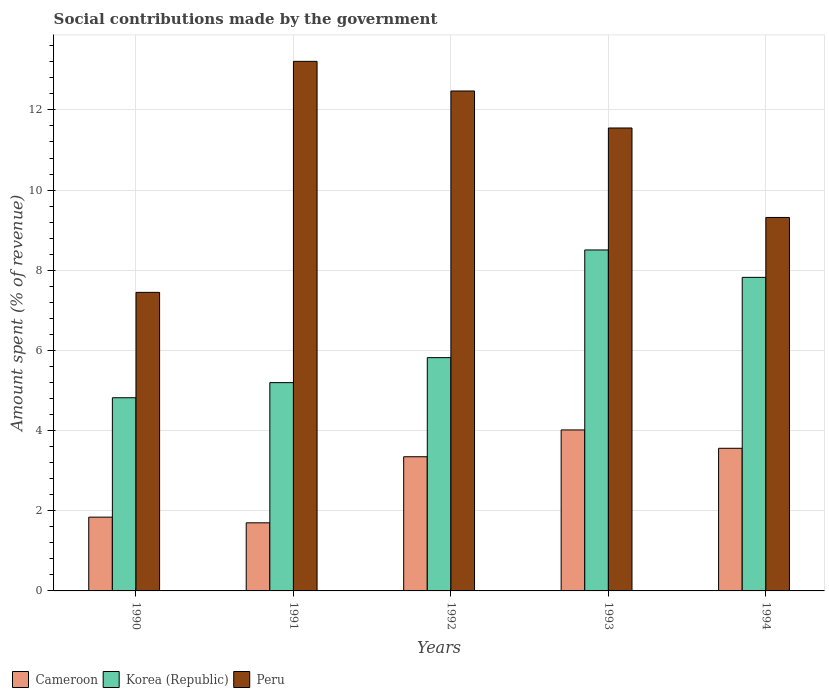How many different coloured bars are there?
Your response must be concise. 3. How many groups of bars are there?
Offer a very short reply. 5. How many bars are there on the 5th tick from the right?
Give a very brief answer. 3. In how many cases, is the number of bars for a given year not equal to the number of legend labels?
Keep it short and to the point. 0. What is the amount spent (in %) on social contributions in Korea (Republic) in 1994?
Keep it short and to the point. 7.82. Across all years, what is the maximum amount spent (in %) on social contributions in Korea (Republic)?
Your answer should be very brief. 8.51. Across all years, what is the minimum amount spent (in %) on social contributions in Peru?
Provide a succinct answer. 7.45. In which year was the amount spent (in %) on social contributions in Peru maximum?
Provide a short and direct response. 1991. What is the total amount spent (in %) on social contributions in Cameroon in the graph?
Give a very brief answer. 14.46. What is the difference between the amount spent (in %) on social contributions in Peru in 1990 and that in 1991?
Ensure brevity in your answer.  -5.76. What is the difference between the amount spent (in %) on social contributions in Peru in 1992 and the amount spent (in %) on social contributions in Cameroon in 1993?
Your answer should be very brief. 8.46. What is the average amount spent (in %) on social contributions in Cameroon per year?
Your answer should be very brief. 2.89. In the year 1992, what is the difference between the amount spent (in %) on social contributions in Cameroon and amount spent (in %) on social contributions in Korea (Republic)?
Your answer should be compact. -2.47. In how many years, is the amount spent (in %) on social contributions in Korea (Republic) greater than 8.4 %?
Your response must be concise. 1. What is the ratio of the amount spent (in %) on social contributions in Korea (Republic) in 1991 to that in 1994?
Your response must be concise. 0.66. What is the difference between the highest and the second highest amount spent (in %) on social contributions in Cameroon?
Give a very brief answer. 0.46. What is the difference between the highest and the lowest amount spent (in %) on social contributions in Peru?
Your answer should be compact. 5.76. In how many years, is the amount spent (in %) on social contributions in Cameroon greater than the average amount spent (in %) on social contributions in Cameroon taken over all years?
Ensure brevity in your answer.  3. Is the sum of the amount spent (in %) on social contributions in Cameroon in 1990 and 1993 greater than the maximum amount spent (in %) on social contributions in Peru across all years?
Offer a terse response. No. What does the 2nd bar from the left in 1991 represents?
Your response must be concise. Korea (Republic). What does the 1st bar from the right in 1991 represents?
Offer a very short reply. Peru. How many bars are there?
Keep it short and to the point. 15. How many years are there in the graph?
Give a very brief answer. 5. Does the graph contain any zero values?
Make the answer very short. No. Where does the legend appear in the graph?
Ensure brevity in your answer.  Bottom left. How many legend labels are there?
Ensure brevity in your answer.  3. What is the title of the graph?
Give a very brief answer. Social contributions made by the government. Does "Low income" appear as one of the legend labels in the graph?
Provide a succinct answer. No. What is the label or title of the X-axis?
Ensure brevity in your answer.  Years. What is the label or title of the Y-axis?
Your answer should be very brief. Amount spent (% of revenue). What is the Amount spent (% of revenue) of Cameroon in 1990?
Ensure brevity in your answer.  1.84. What is the Amount spent (% of revenue) in Korea (Republic) in 1990?
Ensure brevity in your answer.  4.82. What is the Amount spent (% of revenue) of Peru in 1990?
Offer a very short reply. 7.45. What is the Amount spent (% of revenue) of Cameroon in 1991?
Ensure brevity in your answer.  1.7. What is the Amount spent (% of revenue) of Korea (Republic) in 1991?
Keep it short and to the point. 5.2. What is the Amount spent (% of revenue) in Peru in 1991?
Ensure brevity in your answer.  13.21. What is the Amount spent (% of revenue) of Cameroon in 1992?
Give a very brief answer. 3.35. What is the Amount spent (% of revenue) of Korea (Republic) in 1992?
Ensure brevity in your answer.  5.82. What is the Amount spent (% of revenue) of Peru in 1992?
Make the answer very short. 12.47. What is the Amount spent (% of revenue) of Cameroon in 1993?
Offer a terse response. 4.02. What is the Amount spent (% of revenue) in Korea (Republic) in 1993?
Offer a very short reply. 8.51. What is the Amount spent (% of revenue) of Peru in 1993?
Keep it short and to the point. 11.55. What is the Amount spent (% of revenue) in Cameroon in 1994?
Make the answer very short. 3.56. What is the Amount spent (% of revenue) in Korea (Republic) in 1994?
Provide a succinct answer. 7.82. What is the Amount spent (% of revenue) in Peru in 1994?
Make the answer very short. 9.32. Across all years, what is the maximum Amount spent (% of revenue) in Cameroon?
Keep it short and to the point. 4.02. Across all years, what is the maximum Amount spent (% of revenue) of Korea (Republic)?
Offer a terse response. 8.51. Across all years, what is the maximum Amount spent (% of revenue) of Peru?
Provide a short and direct response. 13.21. Across all years, what is the minimum Amount spent (% of revenue) in Cameroon?
Offer a terse response. 1.7. Across all years, what is the minimum Amount spent (% of revenue) in Korea (Republic)?
Your answer should be very brief. 4.82. Across all years, what is the minimum Amount spent (% of revenue) in Peru?
Keep it short and to the point. 7.45. What is the total Amount spent (% of revenue) of Cameroon in the graph?
Your response must be concise. 14.46. What is the total Amount spent (% of revenue) in Korea (Republic) in the graph?
Provide a succinct answer. 32.16. What is the total Amount spent (% of revenue) of Peru in the graph?
Your answer should be compact. 54. What is the difference between the Amount spent (% of revenue) in Cameroon in 1990 and that in 1991?
Give a very brief answer. 0.14. What is the difference between the Amount spent (% of revenue) of Korea (Republic) in 1990 and that in 1991?
Your answer should be compact. -0.38. What is the difference between the Amount spent (% of revenue) in Peru in 1990 and that in 1991?
Your answer should be very brief. -5.76. What is the difference between the Amount spent (% of revenue) in Cameroon in 1990 and that in 1992?
Give a very brief answer. -1.51. What is the difference between the Amount spent (% of revenue) of Korea (Republic) in 1990 and that in 1992?
Give a very brief answer. -1. What is the difference between the Amount spent (% of revenue) of Peru in 1990 and that in 1992?
Ensure brevity in your answer.  -5.02. What is the difference between the Amount spent (% of revenue) in Cameroon in 1990 and that in 1993?
Provide a short and direct response. -2.18. What is the difference between the Amount spent (% of revenue) in Korea (Republic) in 1990 and that in 1993?
Offer a terse response. -3.69. What is the difference between the Amount spent (% of revenue) in Peru in 1990 and that in 1993?
Offer a terse response. -4.1. What is the difference between the Amount spent (% of revenue) of Cameroon in 1990 and that in 1994?
Your answer should be compact. -1.72. What is the difference between the Amount spent (% of revenue) of Korea (Republic) in 1990 and that in 1994?
Provide a short and direct response. -3. What is the difference between the Amount spent (% of revenue) of Peru in 1990 and that in 1994?
Provide a succinct answer. -1.87. What is the difference between the Amount spent (% of revenue) in Cameroon in 1991 and that in 1992?
Your answer should be compact. -1.65. What is the difference between the Amount spent (% of revenue) of Korea (Republic) in 1991 and that in 1992?
Offer a very short reply. -0.62. What is the difference between the Amount spent (% of revenue) of Peru in 1991 and that in 1992?
Give a very brief answer. 0.74. What is the difference between the Amount spent (% of revenue) of Cameroon in 1991 and that in 1993?
Offer a terse response. -2.32. What is the difference between the Amount spent (% of revenue) of Korea (Republic) in 1991 and that in 1993?
Your answer should be compact. -3.31. What is the difference between the Amount spent (% of revenue) in Peru in 1991 and that in 1993?
Ensure brevity in your answer.  1.66. What is the difference between the Amount spent (% of revenue) of Cameroon in 1991 and that in 1994?
Give a very brief answer. -1.86. What is the difference between the Amount spent (% of revenue) of Korea (Republic) in 1991 and that in 1994?
Offer a terse response. -2.63. What is the difference between the Amount spent (% of revenue) in Peru in 1991 and that in 1994?
Give a very brief answer. 3.89. What is the difference between the Amount spent (% of revenue) of Cameroon in 1992 and that in 1993?
Ensure brevity in your answer.  -0.67. What is the difference between the Amount spent (% of revenue) in Korea (Republic) in 1992 and that in 1993?
Ensure brevity in your answer.  -2.69. What is the difference between the Amount spent (% of revenue) in Peru in 1992 and that in 1993?
Offer a terse response. 0.92. What is the difference between the Amount spent (% of revenue) in Cameroon in 1992 and that in 1994?
Provide a succinct answer. -0.21. What is the difference between the Amount spent (% of revenue) in Korea (Republic) in 1992 and that in 1994?
Provide a short and direct response. -2. What is the difference between the Amount spent (% of revenue) in Peru in 1992 and that in 1994?
Ensure brevity in your answer.  3.16. What is the difference between the Amount spent (% of revenue) of Cameroon in 1993 and that in 1994?
Ensure brevity in your answer.  0.46. What is the difference between the Amount spent (% of revenue) of Korea (Republic) in 1993 and that in 1994?
Keep it short and to the point. 0.68. What is the difference between the Amount spent (% of revenue) of Peru in 1993 and that in 1994?
Ensure brevity in your answer.  2.23. What is the difference between the Amount spent (% of revenue) in Cameroon in 1990 and the Amount spent (% of revenue) in Korea (Republic) in 1991?
Keep it short and to the point. -3.36. What is the difference between the Amount spent (% of revenue) of Cameroon in 1990 and the Amount spent (% of revenue) of Peru in 1991?
Ensure brevity in your answer.  -11.37. What is the difference between the Amount spent (% of revenue) in Korea (Republic) in 1990 and the Amount spent (% of revenue) in Peru in 1991?
Offer a terse response. -8.39. What is the difference between the Amount spent (% of revenue) in Cameroon in 1990 and the Amount spent (% of revenue) in Korea (Republic) in 1992?
Your answer should be very brief. -3.98. What is the difference between the Amount spent (% of revenue) of Cameroon in 1990 and the Amount spent (% of revenue) of Peru in 1992?
Offer a terse response. -10.63. What is the difference between the Amount spent (% of revenue) in Korea (Republic) in 1990 and the Amount spent (% of revenue) in Peru in 1992?
Ensure brevity in your answer.  -7.65. What is the difference between the Amount spent (% of revenue) in Cameroon in 1990 and the Amount spent (% of revenue) in Korea (Republic) in 1993?
Ensure brevity in your answer.  -6.67. What is the difference between the Amount spent (% of revenue) in Cameroon in 1990 and the Amount spent (% of revenue) in Peru in 1993?
Ensure brevity in your answer.  -9.71. What is the difference between the Amount spent (% of revenue) in Korea (Republic) in 1990 and the Amount spent (% of revenue) in Peru in 1993?
Provide a succinct answer. -6.73. What is the difference between the Amount spent (% of revenue) in Cameroon in 1990 and the Amount spent (% of revenue) in Korea (Republic) in 1994?
Give a very brief answer. -5.98. What is the difference between the Amount spent (% of revenue) in Cameroon in 1990 and the Amount spent (% of revenue) in Peru in 1994?
Offer a terse response. -7.48. What is the difference between the Amount spent (% of revenue) of Korea (Republic) in 1990 and the Amount spent (% of revenue) of Peru in 1994?
Offer a terse response. -4.5. What is the difference between the Amount spent (% of revenue) in Cameroon in 1991 and the Amount spent (% of revenue) in Korea (Republic) in 1992?
Provide a succinct answer. -4.12. What is the difference between the Amount spent (% of revenue) of Cameroon in 1991 and the Amount spent (% of revenue) of Peru in 1992?
Keep it short and to the point. -10.77. What is the difference between the Amount spent (% of revenue) of Korea (Republic) in 1991 and the Amount spent (% of revenue) of Peru in 1992?
Your answer should be very brief. -7.28. What is the difference between the Amount spent (% of revenue) of Cameroon in 1991 and the Amount spent (% of revenue) of Korea (Republic) in 1993?
Your response must be concise. -6.81. What is the difference between the Amount spent (% of revenue) in Cameroon in 1991 and the Amount spent (% of revenue) in Peru in 1993?
Make the answer very short. -9.85. What is the difference between the Amount spent (% of revenue) in Korea (Republic) in 1991 and the Amount spent (% of revenue) in Peru in 1993?
Your response must be concise. -6.35. What is the difference between the Amount spent (% of revenue) in Cameroon in 1991 and the Amount spent (% of revenue) in Korea (Republic) in 1994?
Provide a short and direct response. -6.12. What is the difference between the Amount spent (% of revenue) of Cameroon in 1991 and the Amount spent (% of revenue) of Peru in 1994?
Your answer should be very brief. -7.62. What is the difference between the Amount spent (% of revenue) in Korea (Republic) in 1991 and the Amount spent (% of revenue) in Peru in 1994?
Your answer should be very brief. -4.12. What is the difference between the Amount spent (% of revenue) of Cameroon in 1992 and the Amount spent (% of revenue) of Korea (Republic) in 1993?
Offer a terse response. -5.16. What is the difference between the Amount spent (% of revenue) of Cameroon in 1992 and the Amount spent (% of revenue) of Peru in 1993?
Keep it short and to the point. -8.2. What is the difference between the Amount spent (% of revenue) in Korea (Republic) in 1992 and the Amount spent (% of revenue) in Peru in 1993?
Keep it short and to the point. -5.73. What is the difference between the Amount spent (% of revenue) of Cameroon in 1992 and the Amount spent (% of revenue) of Korea (Republic) in 1994?
Your answer should be very brief. -4.48. What is the difference between the Amount spent (% of revenue) in Cameroon in 1992 and the Amount spent (% of revenue) in Peru in 1994?
Give a very brief answer. -5.97. What is the difference between the Amount spent (% of revenue) in Korea (Republic) in 1992 and the Amount spent (% of revenue) in Peru in 1994?
Keep it short and to the point. -3.5. What is the difference between the Amount spent (% of revenue) in Cameroon in 1993 and the Amount spent (% of revenue) in Korea (Republic) in 1994?
Give a very brief answer. -3.81. What is the difference between the Amount spent (% of revenue) in Cameroon in 1993 and the Amount spent (% of revenue) in Peru in 1994?
Make the answer very short. -5.3. What is the difference between the Amount spent (% of revenue) in Korea (Republic) in 1993 and the Amount spent (% of revenue) in Peru in 1994?
Ensure brevity in your answer.  -0.81. What is the average Amount spent (% of revenue) of Cameroon per year?
Keep it short and to the point. 2.89. What is the average Amount spent (% of revenue) of Korea (Republic) per year?
Provide a succinct answer. 6.43. What is the average Amount spent (% of revenue) in Peru per year?
Keep it short and to the point. 10.8. In the year 1990, what is the difference between the Amount spent (% of revenue) in Cameroon and Amount spent (% of revenue) in Korea (Republic)?
Make the answer very short. -2.98. In the year 1990, what is the difference between the Amount spent (% of revenue) of Cameroon and Amount spent (% of revenue) of Peru?
Ensure brevity in your answer.  -5.61. In the year 1990, what is the difference between the Amount spent (% of revenue) of Korea (Republic) and Amount spent (% of revenue) of Peru?
Offer a terse response. -2.63. In the year 1991, what is the difference between the Amount spent (% of revenue) in Cameroon and Amount spent (% of revenue) in Korea (Republic)?
Give a very brief answer. -3.5. In the year 1991, what is the difference between the Amount spent (% of revenue) of Cameroon and Amount spent (% of revenue) of Peru?
Your answer should be compact. -11.51. In the year 1991, what is the difference between the Amount spent (% of revenue) of Korea (Republic) and Amount spent (% of revenue) of Peru?
Your answer should be compact. -8.02. In the year 1992, what is the difference between the Amount spent (% of revenue) in Cameroon and Amount spent (% of revenue) in Korea (Republic)?
Your response must be concise. -2.47. In the year 1992, what is the difference between the Amount spent (% of revenue) in Cameroon and Amount spent (% of revenue) in Peru?
Your answer should be compact. -9.12. In the year 1992, what is the difference between the Amount spent (% of revenue) in Korea (Republic) and Amount spent (% of revenue) in Peru?
Your answer should be very brief. -6.65. In the year 1993, what is the difference between the Amount spent (% of revenue) of Cameroon and Amount spent (% of revenue) of Korea (Republic)?
Offer a very short reply. -4.49. In the year 1993, what is the difference between the Amount spent (% of revenue) of Cameroon and Amount spent (% of revenue) of Peru?
Ensure brevity in your answer.  -7.53. In the year 1993, what is the difference between the Amount spent (% of revenue) in Korea (Republic) and Amount spent (% of revenue) in Peru?
Provide a short and direct response. -3.04. In the year 1994, what is the difference between the Amount spent (% of revenue) of Cameroon and Amount spent (% of revenue) of Korea (Republic)?
Your answer should be compact. -4.26. In the year 1994, what is the difference between the Amount spent (% of revenue) of Cameroon and Amount spent (% of revenue) of Peru?
Make the answer very short. -5.76. In the year 1994, what is the difference between the Amount spent (% of revenue) in Korea (Republic) and Amount spent (% of revenue) in Peru?
Offer a very short reply. -1.49. What is the ratio of the Amount spent (% of revenue) in Cameroon in 1990 to that in 1991?
Your answer should be very brief. 1.08. What is the ratio of the Amount spent (% of revenue) in Korea (Republic) in 1990 to that in 1991?
Offer a very short reply. 0.93. What is the ratio of the Amount spent (% of revenue) in Peru in 1990 to that in 1991?
Provide a succinct answer. 0.56. What is the ratio of the Amount spent (% of revenue) in Cameroon in 1990 to that in 1992?
Give a very brief answer. 0.55. What is the ratio of the Amount spent (% of revenue) of Korea (Republic) in 1990 to that in 1992?
Your response must be concise. 0.83. What is the ratio of the Amount spent (% of revenue) in Peru in 1990 to that in 1992?
Give a very brief answer. 0.6. What is the ratio of the Amount spent (% of revenue) of Cameroon in 1990 to that in 1993?
Keep it short and to the point. 0.46. What is the ratio of the Amount spent (% of revenue) of Korea (Republic) in 1990 to that in 1993?
Offer a very short reply. 0.57. What is the ratio of the Amount spent (% of revenue) of Peru in 1990 to that in 1993?
Your answer should be very brief. 0.64. What is the ratio of the Amount spent (% of revenue) of Cameroon in 1990 to that in 1994?
Your answer should be very brief. 0.52. What is the ratio of the Amount spent (% of revenue) of Korea (Republic) in 1990 to that in 1994?
Make the answer very short. 0.62. What is the ratio of the Amount spent (% of revenue) of Peru in 1990 to that in 1994?
Make the answer very short. 0.8. What is the ratio of the Amount spent (% of revenue) of Cameroon in 1991 to that in 1992?
Give a very brief answer. 0.51. What is the ratio of the Amount spent (% of revenue) in Korea (Republic) in 1991 to that in 1992?
Ensure brevity in your answer.  0.89. What is the ratio of the Amount spent (% of revenue) in Peru in 1991 to that in 1992?
Offer a very short reply. 1.06. What is the ratio of the Amount spent (% of revenue) of Cameroon in 1991 to that in 1993?
Offer a terse response. 0.42. What is the ratio of the Amount spent (% of revenue) in Korea (Republic) in 1991 to that in 1993?
Your answer should be very brief. 0.61. What is the ratio of the Amount spent (% of revenue) in Peru in 1991 to that in 1993?
Ensure brevity in your answer.  1.14. What is the ratio of the Amount spent (% of revenue) of Cameroon in 1991 to that in 1994?
Offer a terse response. 0.48. What is the ratio of the Amount spent (% of revenue) of Korea (Republic) in 1991 to that in 1994?
Keep it short and to the point. 0.66. What is the ratio of the Amount spent (% of revenue) of Peru in 1991 to that in 1994?
Keep it short and to the point. 1.42. What is the ratio of the Amount spent (% of revenue) in Cameroon in 1992 to that in 1993?
Provide a short and direct response. 0.83. What is the ratio of the Amount spent (% of revenue) of Korea (Republic) in 1992 to that in 1993?
Give a very brief answer. 0.68. What is the ratio of the Amount spent (% of revenue) of Peru in 1992 to that in 1993?
Offer a terse response. 1.08. What is the ratio of the Amount spent (% of revenue) of Cameroon in 1992 to that in 1994?
Ensure brevity in your answer.  0.94. What is the ratio of the Amount spent (% of revenue) of Korea (Republic) in 1992 to that in 1994?
Offer a terse response. 0.74. What is the ratio of the Amount spent (% of revenue) of Peru in 1992 to that in 1994?
Your response must be concise. 1.34. What is the ratio of the Amount spent (% of revenue) of Cameroon in 1993 to that in 1994?
Ensure brevity in your answer.  1.13. What is the ratio of the Amount spent (% of revenue) of Korea (Republic) in 1993 to that in 1994?
Offer a terse response. 1.09. What is the ratio of the Amount spent (% of revenue) in Peru in 1993 to that in 1994?
Offer a terse response. 1.24. What is the difference between the highest and the second highest Amount spent (% of revenue) in Cameroon?
Keep it short and to the point. 0.46. What is the difference between the highest and the second highest Amount spent (% of revenue) in Korea (Republic)?
Your answer should be very brief. 0.68. What is the difference between the highest and the second highest Amount spent (% of revenue) of Peru?
Give a very brief answer. 0.74. What is the difference between the highest and the lowest Amount spent (% of revenue) in Cameroon?
Provide a short and direct response. 2.32. What is the difference between the highest and the lowest Amount spent (% of revenue) of Korea (Republic)?
Provide a succinct answer. 3.69. What is the difference between the highest and the lowest Amount spent (% of revenue) of Peru?
Provide a succinct answer. 5.76. 